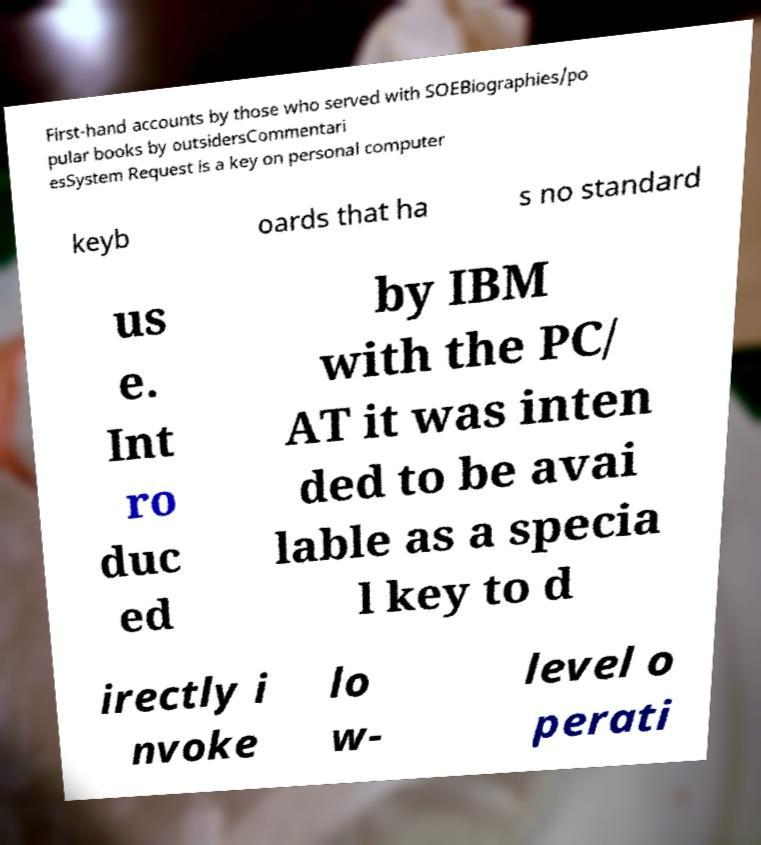Could you assist in decoding the text presented in this image and type it out clearly? First-hand accounts by those who served with SOEBiographies/po pular books by outsidersCommentari esSystem Request is a key on personal computer keyb oards that ha s no standard us e. Int ro duc ed by IBM with the PC/ AT it was inten ded to be avai lable as a specia l key to d irectly i nvoke lo w- level o perati 